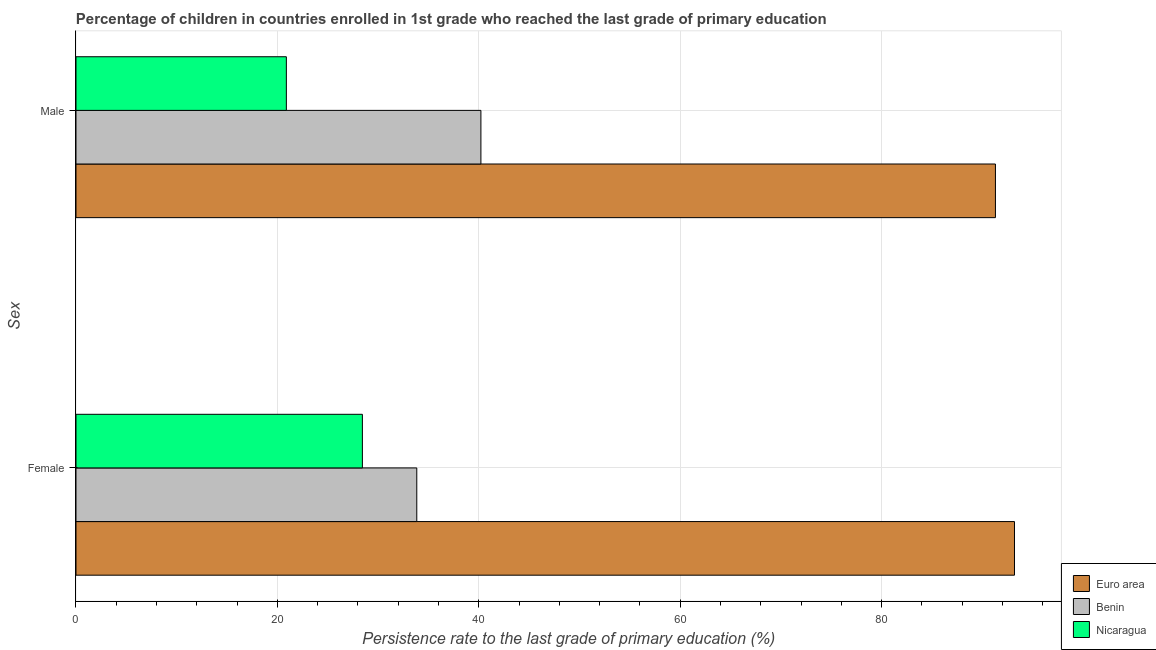What is the persistence rate of male students in Euro area?
Ensure brevity in your answer.  91.31. Across all countries, what is the maximum persistence rate of female students?
Provide a succinct answer. 93.2. Across all countries, what is the minimum persistence rate of female students?
Your answer should be very brief. 28.44. In which country was the persistence rate of male students minimum?
Offer a very short reply. Nicaragua. What is the total persistence rate of male students in the graph?
Offer a very short reply. 152.41. What is the difference between the persistence rate of female students in Benin and that in Euro area?
Your response must be concise. -59.36. What is the difference between the persistence rate of male students in Benin and the persistence rate of female students in Euro area?
Keep it short and to the point. -52.99. What is the average persistence rate of male students per country?
Offer a terse response. 50.8. What is the difference between the persistence rate of male students and persistence rate of female students in Nicaragua?
Make the answer very short. -7.55. What is the ratio of the persistence rate of male students in Nicaragua to that in Benin?
Ensure brevity in your answer.  0.52. In how many countries, is the persistence rate of female students greater than the average persistence rate of female students taken over all countries?
Ensure brevity in your answer.  1. What does the 3rd bar from the top in Female represents?
Your response must be concise. Euro area. What does the 1st bar from the bottom in Female represents?
Give a very brief answer. Euro area. How many bars are there?
Keep it short and to the point. 6. Are all the bars in the graph horizontal?
Give a very brief answer. Yes. How many countries are there in the graph?
Offer a very short reply. 3. What is the difference between two consecutive major ticks on the X-axis?
Give a very brief answer. 20. Does the graph contain any zero values?
Provide a succinct answer. No. Does the graph contain grids?
Your answer should be compact. Yes. Where does the legend appear in the graph?
Your answer should be compact. Bottom right. How are the legend labels stacked?
Keep it short and to the point. Vertical. What is the title of the graph?
Keep it short and to the point. Percentage of children in countries enrolled in 1st grade who reached the last grade of primary education. What is the label or title of the X-axis?
Your answer should be very brief. Persistence rate to the last grade of primary education (%). What is the label or title of the Y-axis?
Offer a terse response. Sex. What is the Persistence rate to the last grade of primary education (%) in Euro area in Female?
Offer a terse response. 93.2. What is the Persistence rate to the last grade of primary education (%) of Benin in Female?
Your answer should be compact. 33.84. What is the Persistence rate to the last grade of primary education (%) of Nicaragua in Female?
Keep it short and to the point. 28.44. What is the Persistence rate to the last grade of primary education (%) in Euro area in Male?
Keep it short and to the point. 91.31. What is the Persistence rate to the last grade of primary education (%) in Benin in Male?
Offer a very short reply. 40.21. What is the Persistence rate to the last grade of primary education (%) of Nicaragua in Male?
Offer a terse response. 20.89. Across all Sex, what is the maximum Persistence rate to the last grade of primary education (%) of Euro area?
Ensure brevity in your answer.  93.2. Across all Sex, what is the maximum Persistence rate to the last grade of primary education (%) in Benin?
Make the answer very short. 40.21. Across all Sex, what is the maximum Persistence rate to the last grade of primary education (%) of Nicaragua?
Make the answer very short. 28.44. Across all Sex, what is the minimum Persistence rate to the last grade of primary education (%) of Euro area?
Your response must be concise. 91.31. Across all Sex, what is the minimum Persistence rate to the last grade of primary education (%) in Benin?
Your answer should be compact. 33.84. Across all Sex, what is the minimum Persistence rate to the last grade of primary education (%) of Nicaragua?
Your response must be concise. 20.89. What is the total Persistence rate to the last grade of primary education (%) of Euro area in the graph?
Keep it short and to the point. 184.51. What is the total Persistence rate to the last grade of primary education (%) of Benin in the graph?
Your answer should be compact. 74.05. What is the total Persistence rate to the last grade of primary education (%) in Nicaragua in the graph?
Ensure brevity in your answer.  49.33. What is the difference between the Persistence rate to the last grade of primary education (%) of Euro area in Female and that in Male?
Ensure brevity in your answer.  1.89. What is the difference between the Persistence rate to the last grade of primary education (%) in Benin in Female and that in Male?
Offer a terse response. -6.37. What is the difference between the Persistence rate to the last grade of primary education (%) of Nicaragua in Female and that in Male?
Give a very brief answer. 7.55. What is the difference between the Persistence rate to the last grade of primary education (%) in Euro area in Female and the Persistence rate to the last grade of primary education (%) in Benin in Male?
Your response must be concise. 52.99. What is the difference between the Persistence rate to the last grade of primary education (%) in Euro area in Female and the Persistence rate to the last grade of primary education (%) in Nicaragua in Male?
Provide a succinct answer. 72.31. What is the difference between the Persistence rate to the last grade of primary education (%) in Benin in Female and the Persistence rate to the last grade of primary education (%) in Nicaragua in Male?
Your response must be concise. 12.95. What is the average Persistence rate to the last grade of primary education (%) in Euro area per Sex?
Your answer should be very brief. 92.25. What is the average Persistence rate to the last grade of primary education (%) in Benin per Sex?
Your answer should be very brief. 37.03. What is the average Persistence rate to the last grade of primary education (%) in Nicaragua per Sex?
Your response must be concise. 24.67. What is the difference between the Persistence rate to the last grade of primary education (%) in Euro area and Persistence rate to the last grade of primary education (%) in Benin in Female?
Give a very brief answer. 59.36. What is the difference between the Persistence rate to the last grade of primary education (%) in Euro area and Persistence rate to the last grade of primary education (%) in Nicaragua in Female?
Provide a short and direct response. 64.76. What is the difference between the Persistence rate to the last grade of primary education (%) in Benin and Persistence rate to the last grade of primary education (%) in Nicaragua in Female?
Make the answer very short. 5.4. What is the difference between the Persistence rate to the last grade of primary education (%) in Euro area and Persistence rate to the last grade of primary education (%) in Benin in Male?
Your answer should be very brief. 51.1. What is the difference between the Persistence rate to the last grade of primary education (%) of Euro area and Persistence rate to the last grade of primary education (%) of Nicaragua in Male?
Provide a succinct answer. 70.42. What is the difference between the Persistence rate to the last grade of primary education (%) of Benin and Persistence rate to the last grade of primary education (%) of Nicaragua in Male?
Your response must be concise. 19.32. What is the ratio of the Persistence rate to the last grade of primary education (%) in Euro area in Female to that in Male?
Your answer should be very brief. 1.02. What is the ratio of the Persistence rate to the last grade of primary education (%) in Benin in Female to that in Male?
Provide a short and direct response. 0.84. What is the ratio of the Persistence rate to the last grade of primary education (%) of Nicaragua in Female to that in Male?
Ensure brevity in your answer.  1.36. What is the difference between the highest and the second highest Persistence rate to the last grade of primary education (%) of Euro area?
Offer a very short reply. 1.89. What is the difference between the highest and the second highest Persistence rate to the last grade of primary education (%) of Benin?
Keep it short and to the point. 6.37. What is the difference between the highest and the second highest Persistence rate to the last grade of primary education (%) of Nicaragua?
Offer a very short reply. 7.55. What is the difference between the highest and the lowest Persistence rate to the last grade of primary education (%) in Euro area?
Your answer should be compact. 1.89. What is the difference between the highest and the lowest Persistence rate to the last grade of primary education (%) of Benin?
Your answer should be compact. 6.37. What is the difference between the highest and the lowest Persistence rate to the last grade of primary education (%) in Nicaragua?
Ensure brevity in your answer.  7.55. 